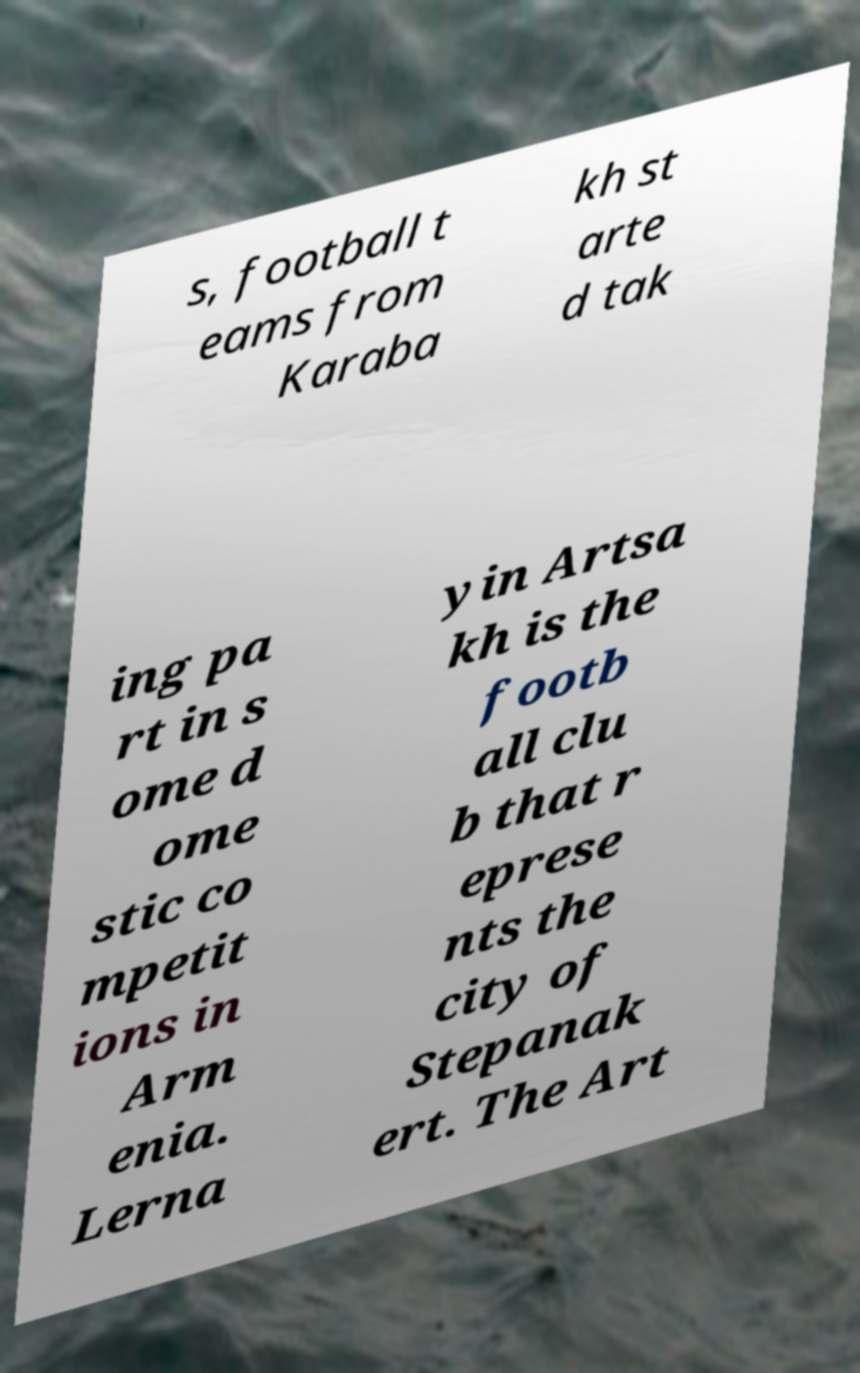For documentation purposes, I need the text within this image transcribed. Could you provide that? s, football t eams from Karaba kh st arte d tak ing pa rt in s ome d ome stic co mpetit ions in Arm enia. Lerna yin Artsa kh is the footb all clu b that r eprese nts the city of Stepanak ert. The Art 